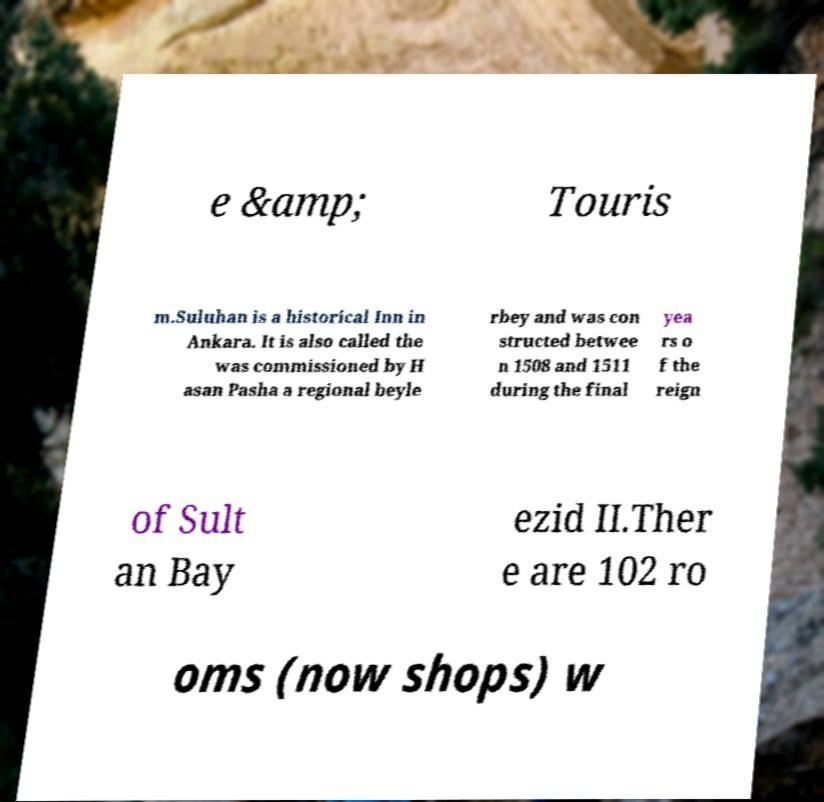Could you extract and type out the text from this image? e &amp; Touris m.Suluhan is a historical Inn in Ankara. It is also called the was commissioned by H asan Pasha a regional beyle rbey and was con structed betwee n 1508 and 1511 during the final yea rs o f the reign of Sult an Bay ezid II.Ther e are 102 ro oms (now shops) w 